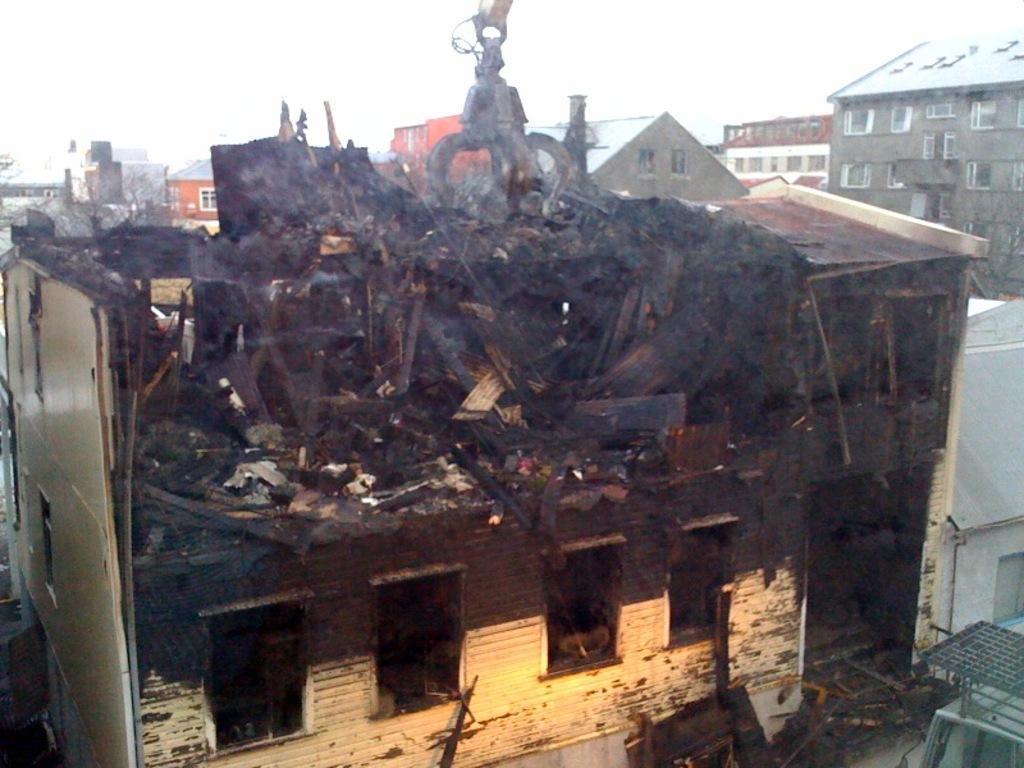Please provide a concise description of this image. In the image there is a renovated building in the front and behind it there are many buildings all over the place and above its sky. 